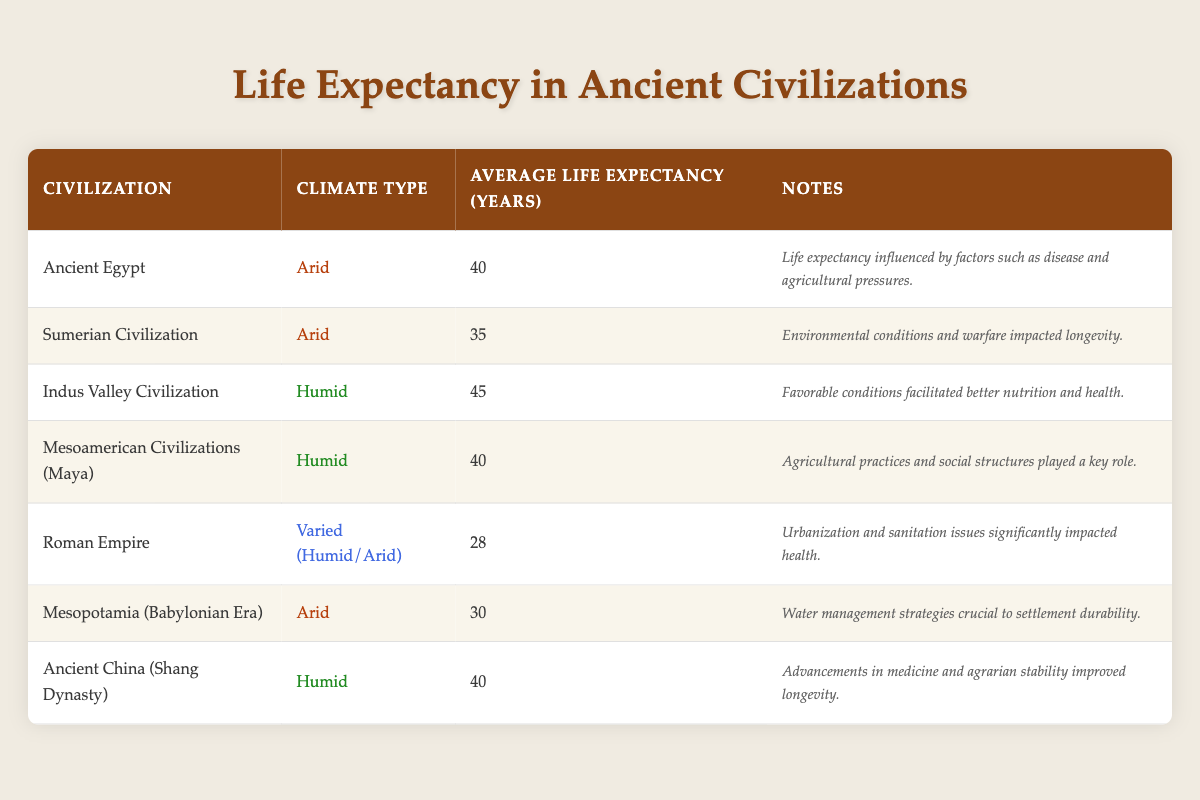What is the average life expectancy of the civilizations in arid climates? The civilizations listed under arid climates are Ancient Egypt (40 years), Sumerian Civilization (35 years), and Mesopotamia (30 years). Therefore, to calculate the average, we add these values: (40 + 35 + 30) = 105. Then, we divide by the number of civilizations: 105 / 3 = 35.
Answer: 35 Which civilization has the highest life expectancy in humid climates? Looking at the humid climate section, we find the Indus Valley Civilization with a life expectancy of 45 years, which is higher than the Maya (40 years) and Ancient China (40 years).
Answer: Indus Valley Civilization Is the average life expectancy of humid climates higher than that of arid climates? The average life expectancy for humid climates is obtained by averaging the values: (45 + 40 + 40) = 125, then dividing by 3: 125 / 3 = approximately 41.67. For arid climates: average calculated previously is 35. Since 41.67 > 35, the statement is true.
Answer: Yes What was the life expectancy of the Roman Empire in comparison to other civilizations listed? The Roman Empire's life expectancy is indicated as 28 years, which is lower than all other civilizations listed (the lowest among them was Mesopotamia at 30 years).
Answer: 28 Did any civilization in a humid climate have a lower life expectancy than 35 years? The humid climate civilizations are the Indus Valley (45 years), Maya (40 years), and Ancient China (40 years). None of these have life expectancies lower than 35 years, so the answer is no.
Answer: No How many years did the average life expectancy for the Sumerian Civilization differ from that of the Ancient China of the humid climate? The life expectancy of Sumerian Civilization is 35 years, while Ancient China is 40 years. The difference is calculated by subtracting Sumerian's life expectancy from Ancient China's: 40 - 35 = 5 years.
Answer: 5 Which climate type correlates with better overall life expectancy based on the civilizations analyzed? From the table, humid climates have an average life expectancy of approximately 41.67 years compared to arid climates' 35 years. Hence, humid climates consistently correlate with better life expectancy.
Answer: Humid What percentage of the civilizations studied had an average life expectancy of 40 years or more? Four civilizations meet that criterion: Indus Valley (45), Ancient Egypt (40), Ancient China (40), and Maya (40). The total number of civilizations is seven, so the percentage is (4/7) * 100 = approximately 57.14%.
Answer: 57.14% 